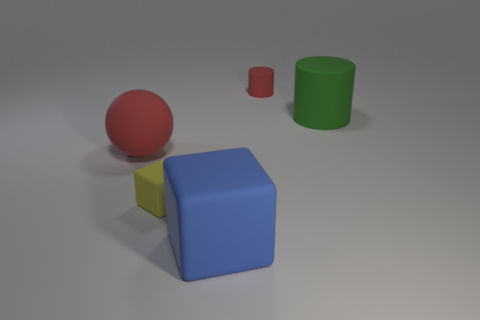Does the tiny yellow block have the same material as the large cylinder?
Your response must be concise. Yes. There is a big green matte object; what number of blue rubber objects are behind it?
Provide a succinct answer. 0. What size is the other thing that is the same shape as the yellow rubber thing?
Provide a succinct answer. Large. What number of blue objects are metallic blocks or big blocks?
Ensure brevity in your answer.  1. There is a large object that is on the left side of the yellow rubber object; how many green cylinders are in front of it?
Your answer should be compact. 0. What number of other things are there of the same shape as the big red matte thing?
Keep it short and to the point. 0. What material is the cylinder that is the same color as the sphere?
Ensure brevity in your answer.  Rubber. What number of other large cylinders are the same color as the large cylinder?
Make the answer very short. 0. There is a cube that is the same material as the blue object; what color is it?
Offer a very short reply. Yellow. Is there another yellow matte block that has the same size as the yellow matte block?
Keep it short and to the point. No. 